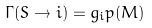<formula> <loc_0><loc_0><loc_500><loc_500>\Gamma ( S \to i ) = g _ { i } p ( M )</formula> 